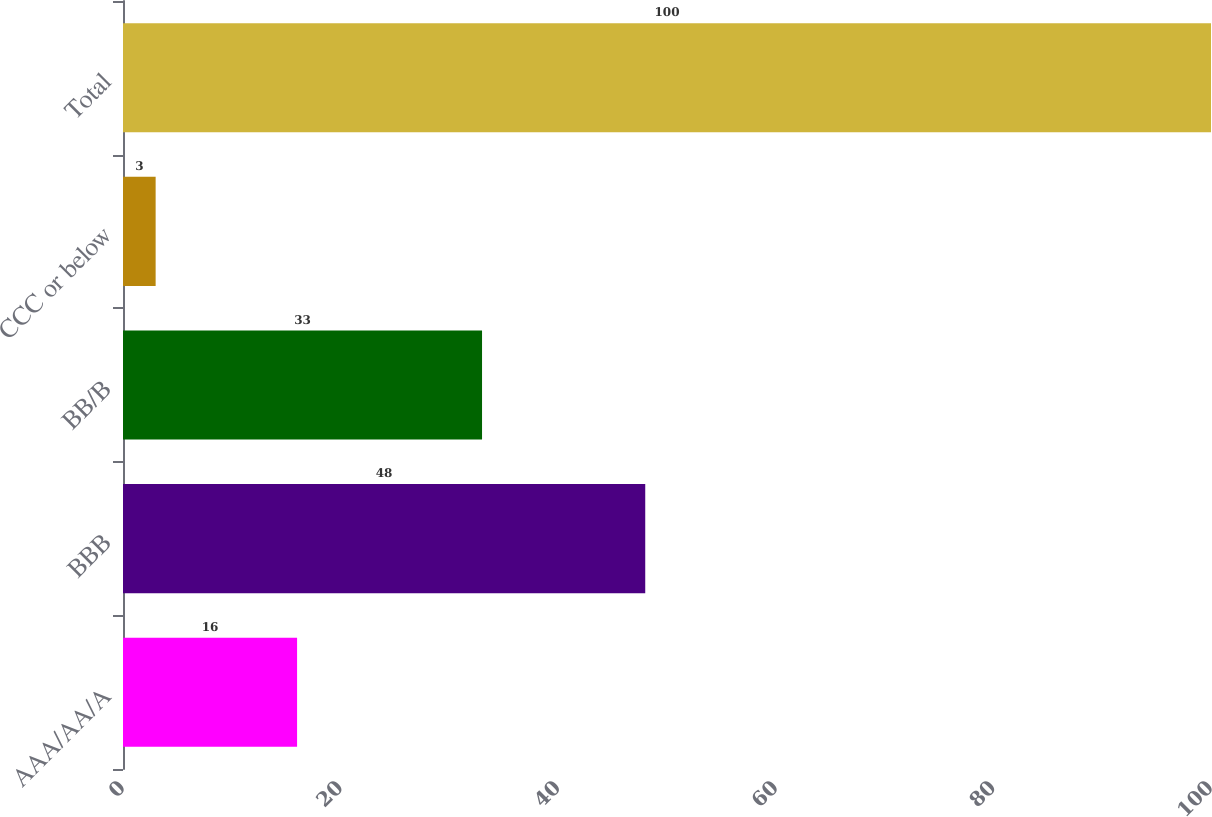Convert chart. <chart><loc_0><loc_0><loc_500><loc_500><bar_chart><fcel>AAA/AA/A<fcel>BBB<fcel>BB/B<fcel>CCC or below<fcel>Total<nl><fcel>16<fcel>48<fcel>33<fcel>3<fcel>100<nl></chart> 